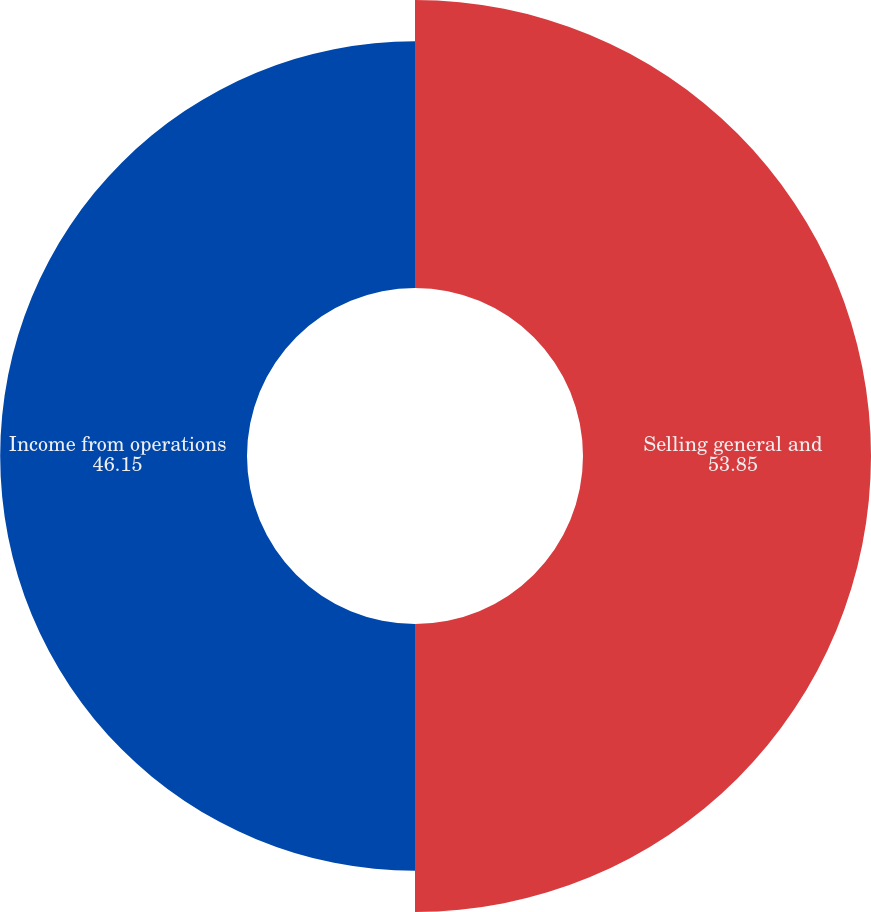Convert chart to OTSL. <chart><loc_0><loc_0><loc_500><loc_500><pie_chart><fcel>Selling general and<fcel>Income from operations<nl><fcel>53.85%<fcel>46.15%<nl></chart> 